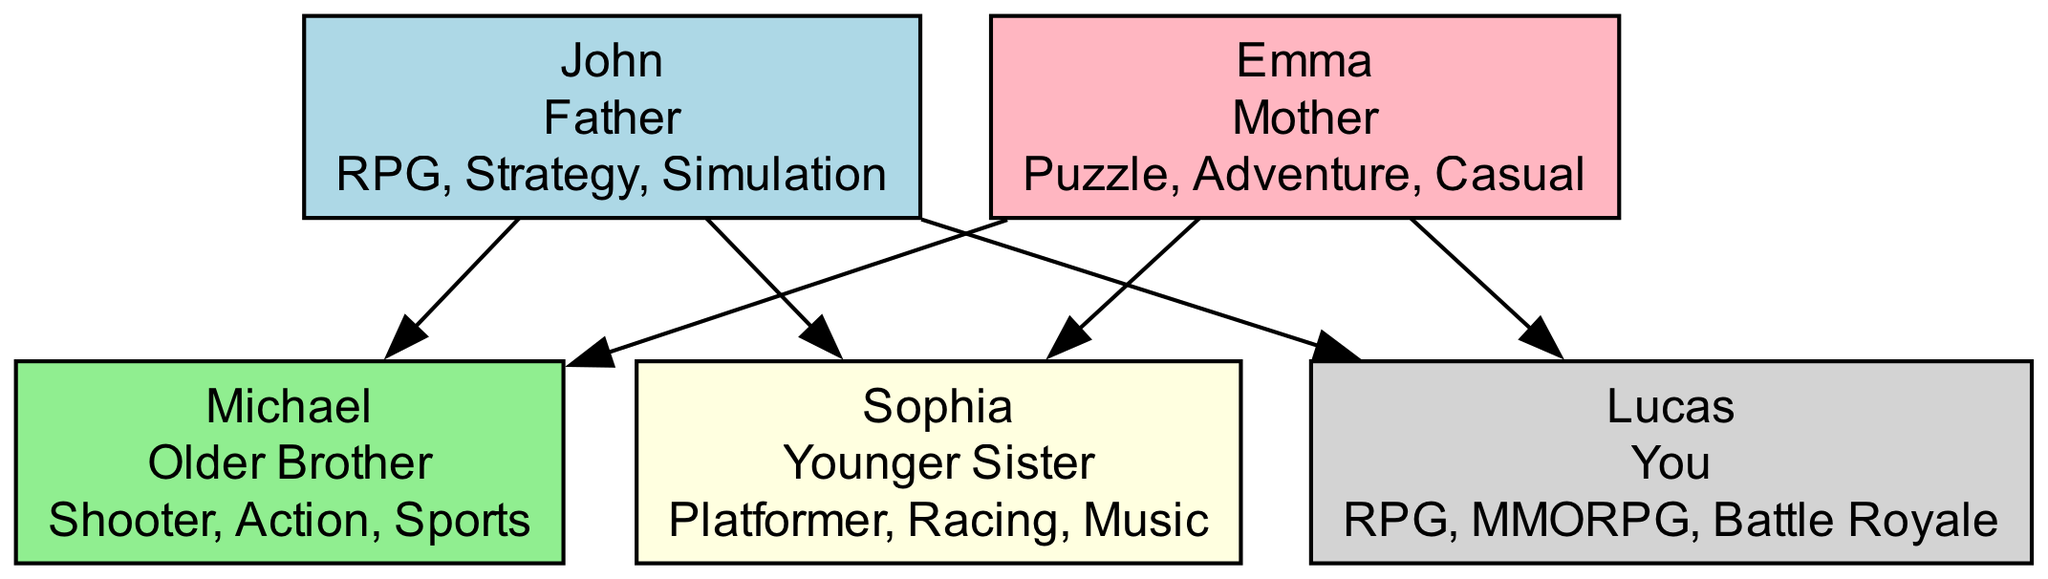What is the favorite genre of John? From the diagram, we can see that John has RPG, Strategy, and Simulation listed as his favorite genres. This information is directly part of the node corresponding to John.
Answer: RPG, Strategy, Simulation How many family members are in the diagram? The diagram illustrates five family members: John, Emma, Michael, Sophia, and Lucas. Counting these nodes gives us the total number of family members represented.
Answer: 5 What genre is shared between John and Lucas? By examining the favorite genres of both John and Lucas, we see that RPG is the genre common to both. This requires comparing the lists of genres for each family member.
Answer: RPG Who prefers Puzzle games? Looking at the diagram, it is clear that Emma is the family member who has Puzzle as one of her favorite genres. This is found in her respective node.
Answer: Emma Which family member has the most genres? When we analyze the favorite genres for each family member, John has three genres (RPG, Strategy, Simulation), while others have either two or three, but no one has more than three. Thus, John has the most genres.
Answer: John What is the relationship between Michael and Lucas? The diagram shows that both Michael and Lucas are children of John and Emma, making them siblings. To find this relationship, we look at the connections created by the edges from the parents to the children.
Answer: Siblings What is Sophia’s favorite genre? Referring to Sophia's node in the diagram, we find that her favorite genres include Platformer, Racing, and Music. This information specifically pertains to her preferences stated in the diagram.
Answer: Platformer, Racing, Music Which parent has the favorite genre of Adventure? Analyzing the nodes reveals that Adventure is one of the favorite genres of Emma. This requires checking the genres attached to each parent node in the diagram.
Answer: Emma 